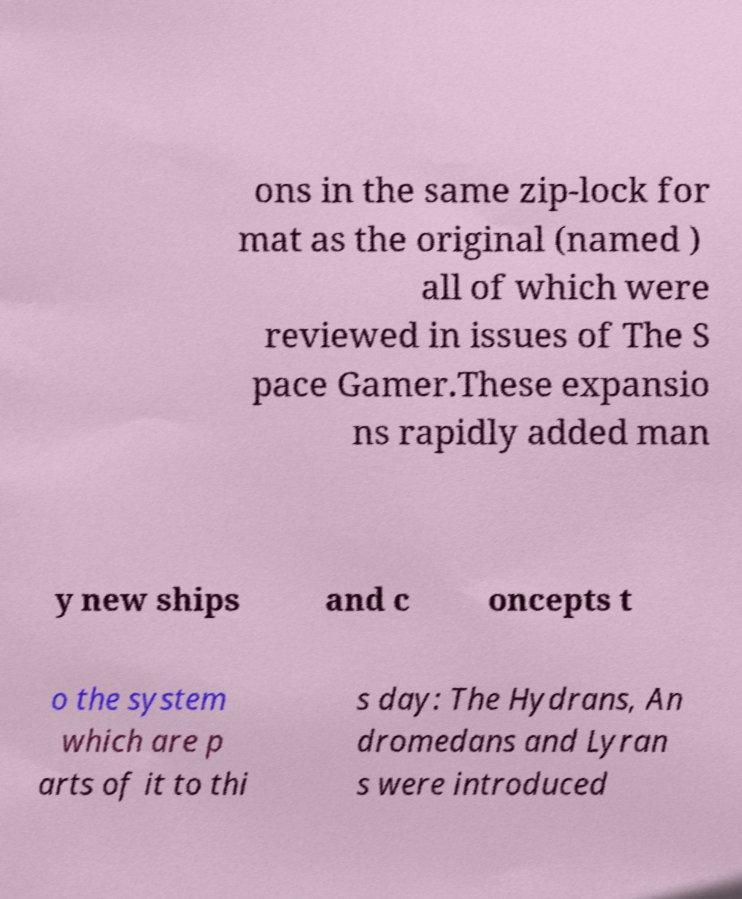Could you assist in decoding the text presented in this image and type it out clearly? ons in the same zip-lock for mat as the original (named ) all of which were reviewed in issues of The S pace Gamer.These expansio ns rapidly added man y new ships and c oncepts t o the system which are p arts of it to thi s day: The Hydrans, An dromedans and Lyran s were introduced 